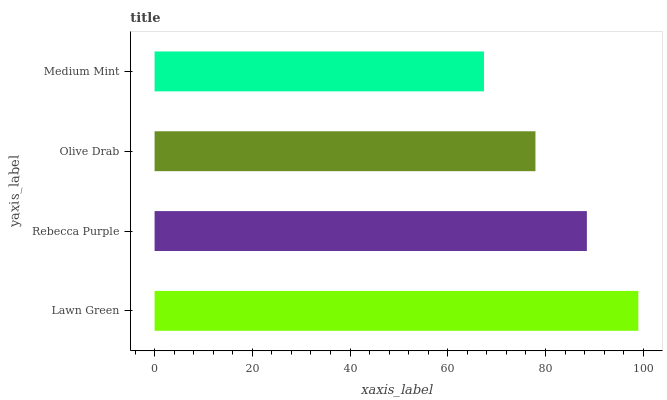Is Medium Mint the minimum?
Answer yes or no. Yes. Is Lawn Green the maximum?
Answer yes or no. Yes. Is Rebecca Purple the minimum?
Answer yes or no. No. Is Rebecca Purple the maximum?
Answer yes or no. No. Is Lawn Green greater than Rebecca Purple?
Answer yes or no. Yes. Is Rebecca Purple less than Lawn Green?
Answer yes or no. Yes. Is Rebecca Purple greater than Lawn Green?
Answer yes or no. No. Is Lawn Green less than Rebecca Purple?
Answer yes or no. No. Is Rebecca Purple the high median?
Answer yes or no. Yes. Is Olive Drab the low median?
Answer yes or no. Yes. Is Lawn Green the high median?
Answer yes or no. No. Is Medium Mint the low median?
Answer yes or no. No. 